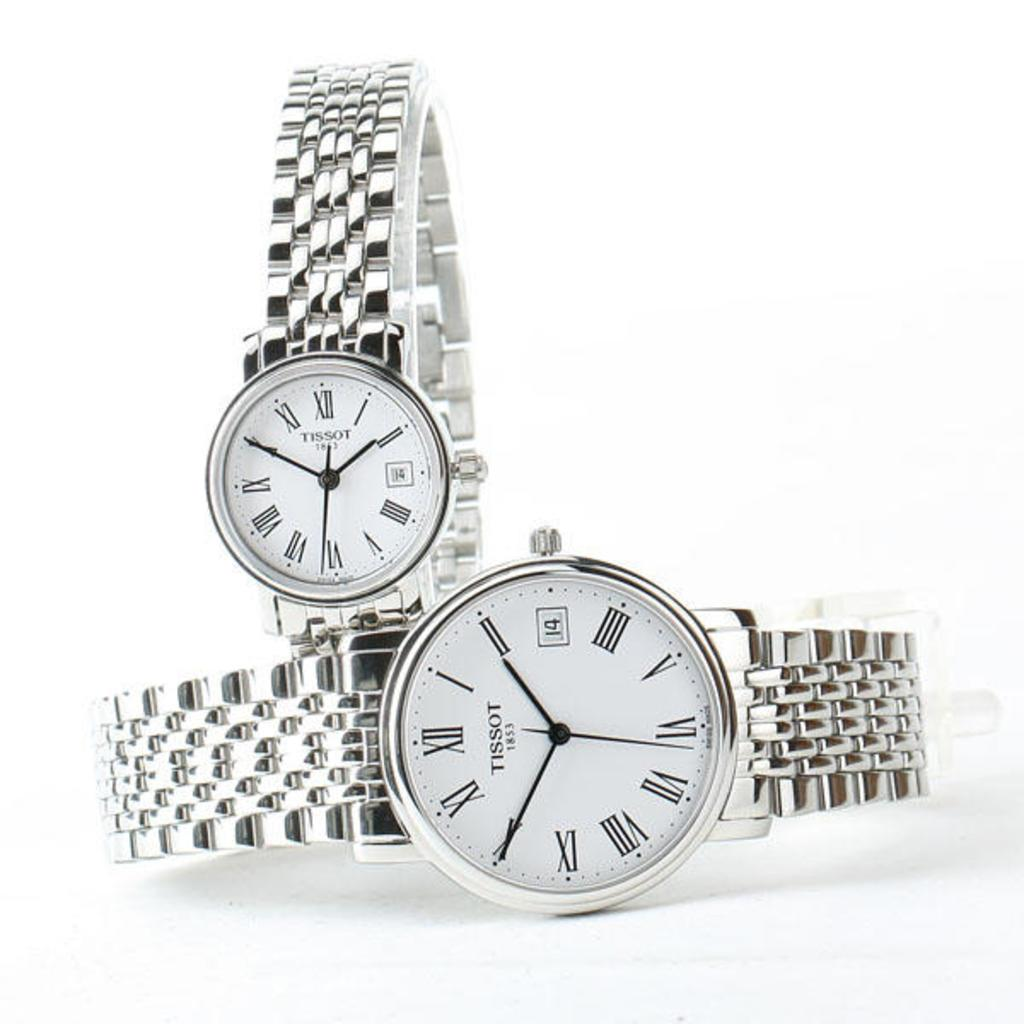<image>
Summarize the visual content of the image. two silver Tissot 1853 watches on a white background 